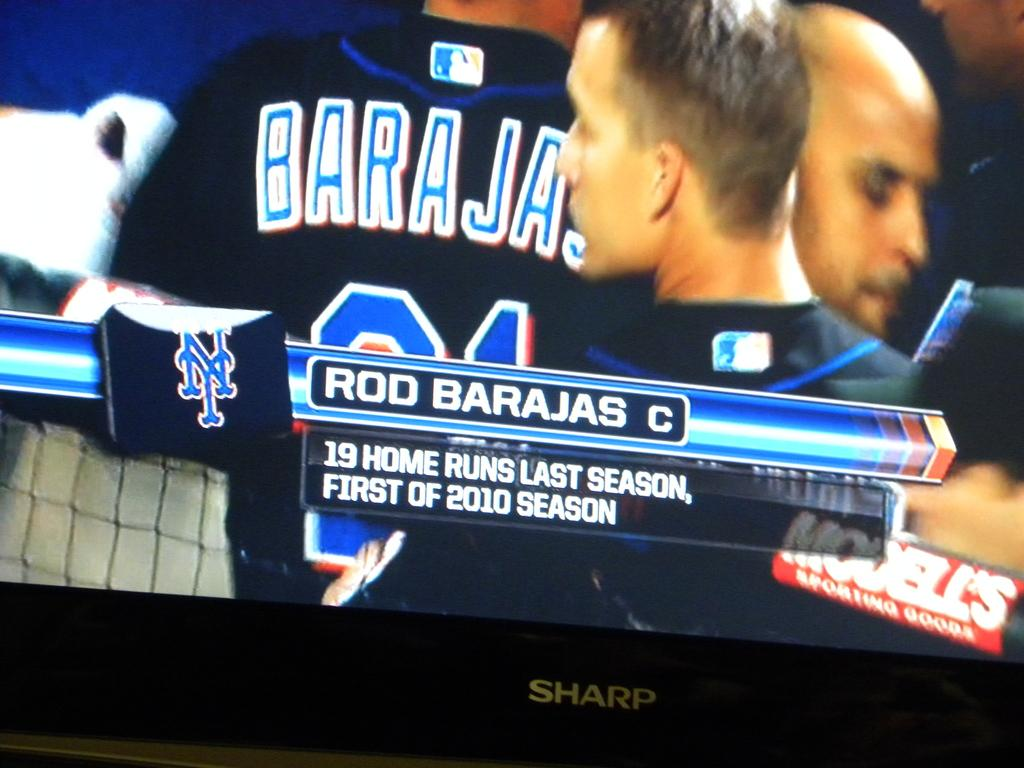<image>
Summarize the visual content of the image. A flat screen TV has a baseball game on it and says Rod Barajas. 